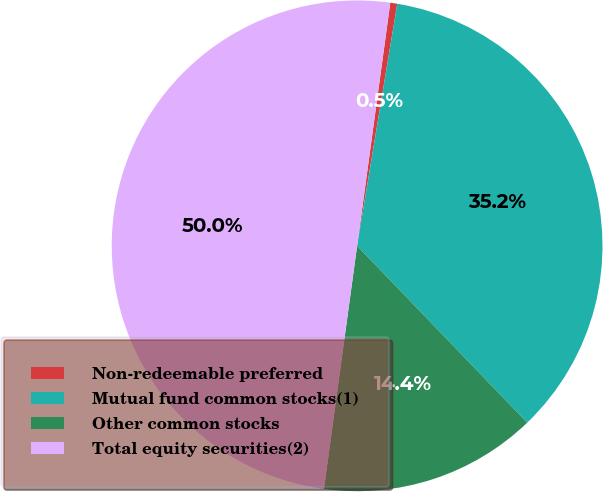Convert chart to OTSL. <chart><loc_0><loc_0><loc_500><loc_500><pie_chart><fcel>Non-redeemable preferred<fcel>Mutual fund common stocks(1)<fcel>Other common stocks<fcel>Total equity securities(2)<nl><fcel>0.46%<fcel>35.19%<fcel>14.35%<fcel>50.0%<nl></chart> 